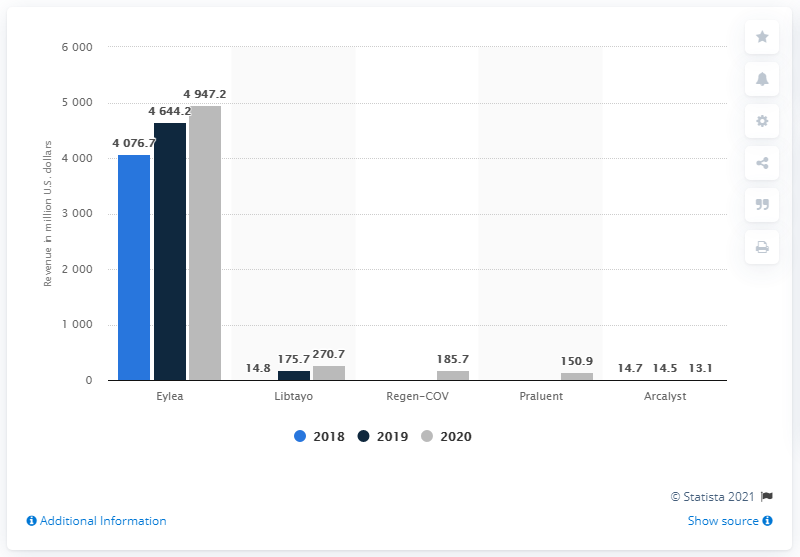Give some essential details in this illustration. The net sales of Libtayo in 2020 were 270.7 million dollars. Eylea was the top-selling Regeneron drug in the United States from 2018 to 2020. 